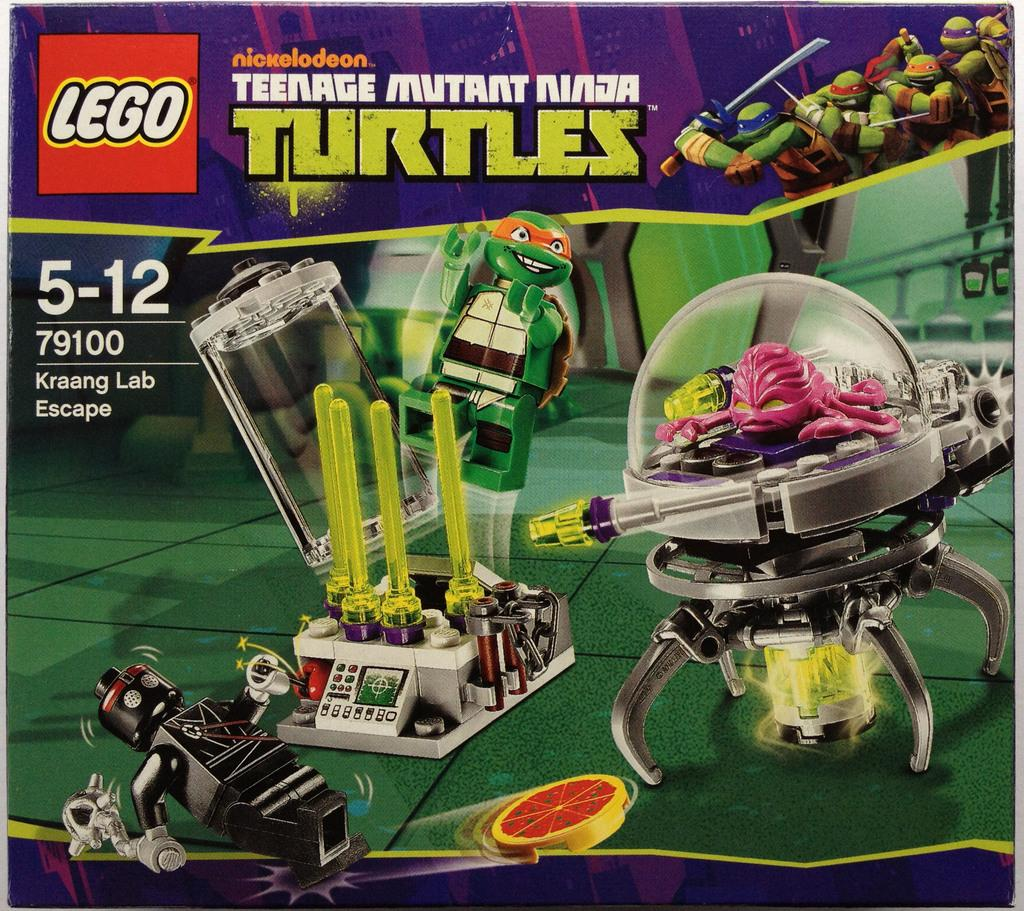<image>
Provide a brief description of the given image. A Lego package with the Teenage Mutant Ninja Turtles theme and its box. 